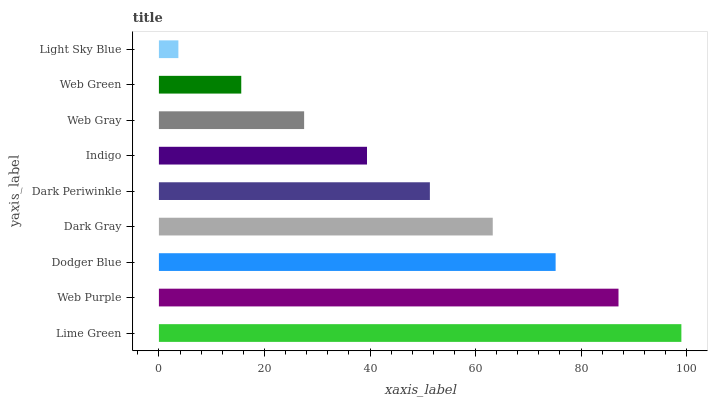Is Light Sky Blue the minimum?
Answer yes or no. Yes. Is Lime Green the maximum?
Answer yes or no. Yes. Is Web Purple the minimum?
Answer yes or no. No. Is Web Purple the maximum?
Answer yes or no. No. Is Lime Green greater than Web Purple?
Answer yes or no. Yes. Is Web Purple less than Lime Green?
Answer yes or no. Yes. Is Web Purple greater than Lime Green?
Answer yes or no. No. Is Lime Green less than Web Purple?
Answer yes or no. No. Is Dark Periwinkle the high median?
Answer yes or no. Yes. Is Dark Periwinkle the low median?
Answer yes or no. Yes. Is Web Green the high median?
Answer yes or no. No. Is Web Gray the low median?
Answer yes or no. No. 